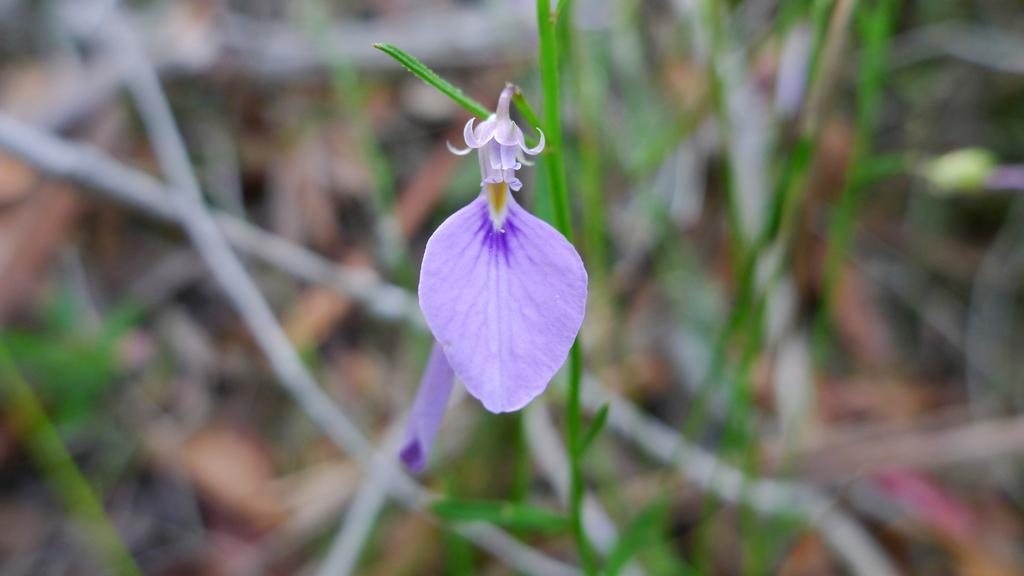What type of living organisms can be seen in the image? Plants and a flower are visible in the image. What color is the flower in the image? The flower is purple in color. Can you see a baby playing with a tiger in the image? No, there is no baby or tiger present in the image; it features plants and a purple flower. 